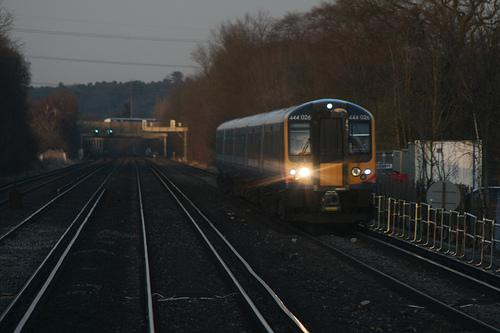Question: what is on the tracks?
Choices:
A. A car.
B. Train.
C. A bus.
D. A bicycle.
Answer with the letter. Answer: B Question: how many train are shown?
Choices:
A. Two.
B. One.
C. Three.
D. Four.
Answer with the letter. Answer: B 